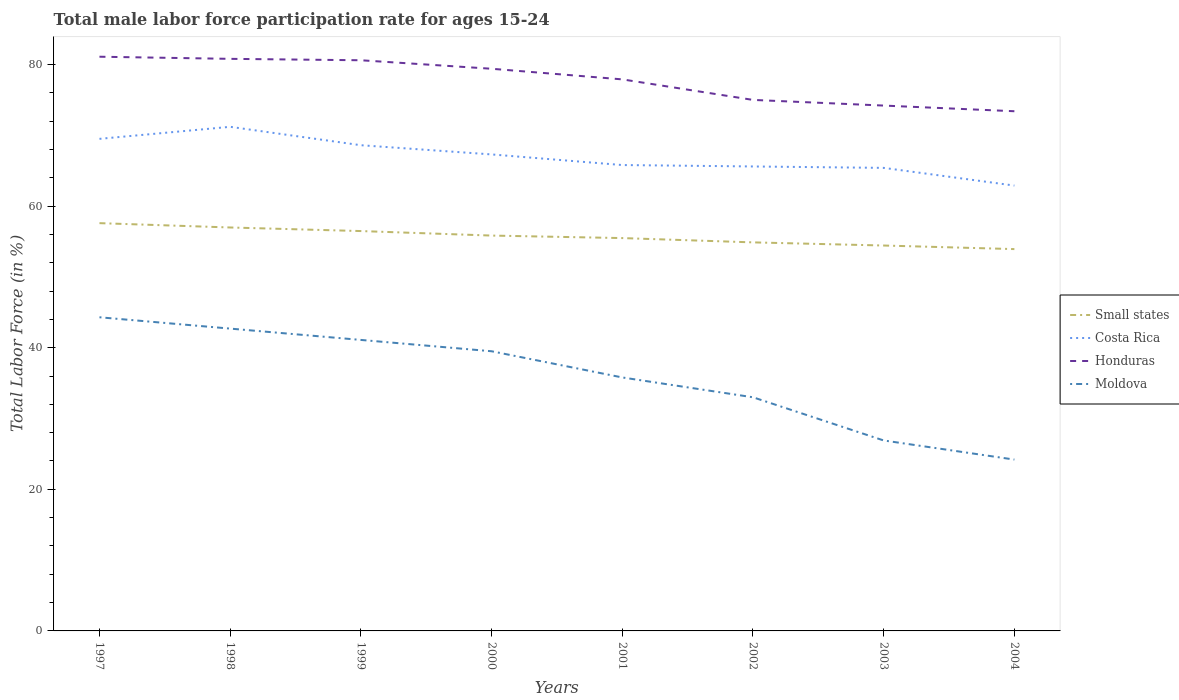How many different coloured lines are there?
Your answer should be compact. 4. Does the line corresponding to Small states intersect with the line corresponding to Moldova?
Give a very brief answer. No. Across all years, what is the maximum male labor force participation rate in Honduras?
Offer a very short reply. 73.4. In which year was the male labor force participation rate in Costa Rica maximum?
Ensure brevity in your answer.  2004. What is the total male labor force participation rate in Costa Rica in the graph?
Make the answer very short. 3.7. What is the difference between the highest and the second highest male labor force participation rate in Honduras?
Offer a very short reply. 7.7. How many lines are there?
Ensure brevity in your answer.  4. How many years are there in the graph?
Make the answer very short. 8. Are the values on the major ticks of Y-axis written in scientific E-notation?
Provide a short and direct response. No. Where does the legend appear in the graph?
Provide a succinct answer. Center right. How are the legend labels stacked?
Ensure brevity in your answer.  Vertical. What is the title of the graph?
Provide a succinct answer. Total male labor force participation rate for ages 15-24. Does "Cabo Verde" appear as one of the legend labels in the graph?
Provide a succinct answer. No. What is the Total Labor Force (in %) in Small states in 1997?
Ensure brevity in your answer.  57.59. What is the Total Labor Force (in %) of Costa Rica in 1997?
Your answer should be compact. 69.5. What is the Total Labor Force (in %) in Honduras in 1997?
Keep it short and to the point. 81.1. What is the Total Labor Force (in %) in Moldova in 1997?
Make the answer very short. 44.3. What is the Total Labor Force (in %) in Small states in 1998?
Offer a terse response. 56.98. What is the Total Labor Force (in %) of Costa Rica in 1998?
Give a very brief answer. 71.2. What is the Total Labor Force (in %) of Honduras in 1998?
Give a very brief answer. 80.8. What is the Total Labor Force (in %) of Moldova in 1998?
Give a very brief answer. 42.7. What is the Total Labor Force (in %) of Small states in 1999?
Provide a short and direct response. 56.48. What is the Total Labor Force (in %) in Costa Rica in 1999?
Make the answer very short. 68.6. What is the Total Labor Force (in %) in Honduras in 1999?
Your answer should be compact. 80.6. What is the Total Labor Force (in %) of Moldova in 1999?
Offer a very short reply. 41.1. What is the Total Labor Force (in %) of Small states in 2000?
Provide a short and direct response. 55.84. What is the Total Labor Force (in %) in Costa Rica in 2000?
Offer a terse response. 67.3. What is the Total Labor Force (in %) of Honduras in 2000?
Your response must be concise. 79.4. What is the Total Labor Force (in %) in Moldova in 2000?
Keep it short and to the point. 39.5. What is the Total Labor Force (in %) in Small states in 2001?
Provide a succinct answer. 55.48. What is the Total Labor Force (in %) in Costa Rica in 2001?
Offer a very short reply. 65.8. What is the Total Labor Force (in %) in Honduras in 2001?
Provide a short and direct response. 77.9. What is the Total Labor Force (in %) of Moldova in 2001?
Your response must be concise. 35.8. What is the Total Labor Force (in %) of Small states in 2002?
Offer a very short reply. 54.88. What is the Total Labor Force (in %) in Costa Rica in 2002?
Make the answer very short. 65.6. What is the Total Labor Force (in %) of Honduras in 2002?
Provide a short and direct response. 75. What is the Total Labor Force (in %) of Small states in 2003?
Provide a succinct answer. 54.43. What is the Total Labor Force (in %) of Costa Rica in 2003?
Your response must be concise. 65.4. What is the Total Labor Force (in %) in Honduras in 2003?
Your answer should be very brief. 74.2. What is the Total Labor Force (in %) in Moldova in 2003?
Your answer should be very brief. 26.9. What is the Total Labor Force (in %) in Small states in 2004?
Offer a very short reply. 53.93. What is the Total Labor Force (in %) of Costa Rica in 2004?
Ensure brevity in your answer.  62.9. What is the Total Labor Force (in %) in Honduras in 2004?
Your answer should be compact. 73.4. What is the Total Labor Force (in %) in Moldova in 2004?
Ensure brevity in your answer.  24.2. Across all years, what is the maximum Total Labor Force (in %) of Small states?
Make the answer very short. 57.59. Across all years, what is the maximum Total Labor Force (in %) of Costa Rica?
Your answer should be very brief. 71.2. Across all years, what is the maximum Total Labor Force (in %) of Honduras?
Offer a very short reply. 81.1. Across all years, what is the maximum Total Labor Force (in %) of Moldova?
Provide a succinct answer. 44.3. Across all years, what is the minimum Total Labor Force (in %) in Small states?
Offer a very short reply. 53.93. Across all years, what is the minimum Total Labor Force (in %) in Costa Rica?
Give a very brief answer. 62.9. Across all years, what is the minimum Total Labor Force (in %) of Honduras?
Provide a succinct answer. 73.4. Across all years, what is the minimum Total Labor Force (in %) in Moldova?
Provide a succinct answer. 24.2. What is the total Total Labor Force (in %) of Small states in the graph?
Your answer should be very brief. 445.62. What is the total Total Labor Force (in %) in Costa Rica in the graph?
Provide a short and direct response. 536.3. What is the total Total Labor Force (in %) in Honduras in the graph?
Make the answer very short. 622.4. What is the total Total Labor Force (in %) of Moldova in the graph?
Offer a very short reply. 287.5. What is the difference between the Total Labor Force (in %) in Small states in 1997 and that in 1998?
Your response must be concise. 0.61. What is the difference between the Total Labor Force (in %) of Costa Rica in 1997 and that in 1998?
Make the answer very short. -1.7. What is the difference between the Total Labor Force (in %) of Honduras in 1997 and that in 1998?
Ensure brevity in your answer.  0.3. What is the difference between the Total Labor Force (in %) in Small states in 1997 and that in 1999?
Provide a succinct answer. 1.12. What is the difference between the Total Labor Force (in %) of Costa Rica in 1997 and that in 1999?
Your answer should be very brief. 0.9. What is the difference between the Total Labor Force (in %) of Honduras in 1997 and that in 1999?
Offer a very short reply. 0.5. What is the difference between the Total Labor Force (in %) in Moldova in 1997 and that in 1999?
Your response must be concise. 3.2. What is the difference between the Total Labor Force (in %) in Small states in 1997 and that in 2000?
Your answer should be very brief. 1.75. What is the difference between the Total Labor Force (in %) in Costa Rica in 1997 and that in 2000?
Provide a short and direct response. 2.2. What is the difference between the Total Labor Force (in %) in Honduras in 1997 and that in 2000?
Offer a terse response. 1.7. What is the difference between the Total Labor Force (in %) in Small states in 1997 and that in 2001?
Provide a succinct answer. 2.11. What is the difference between the Total Labor Force (in %) of Small states in 1997 and that in 2002?
Your response must be concise. 2.72. What is the difference between the Total Labor Force (in %) of Honduras in 1997 and that in 2002?
Keep it short and to the point. 6.1. What is the difference between the Total Labor Force (in %) of Small states in 1997 and that in 2003?
Your answer should be compact. 3.16. What is the difference between the Total Labor Force (in %) in Honduras in 1997 and that in 2003?
Keep it short and to the point. 6.9. What is the difference between the Total Labor Force (in %) in Small states in 1997 and that in 2004?
Give a very brief answer. 3.67. What is the difference between the Total Labor Force (in %) in Honduras in 1997 and that in 2004?
Your answer should be compact. 7.7. What is the difference between the Total Labor Force (in %) of Moldova in 1997 and that in 2004?
Your answer should be very brief. 20.1. What is the difference between the Total Labor Force (in %) in Small states in 1998 and that in 1999?
Your response must be concise. 0.51. What is the difference between the Total Labor Force (in %) of Moldova in 1998 and that in 1999?
Your answer should be very brief. 1.6. What is the difference between the Total Labor Force (in %) of Small states in 1998 and that in 2000?
Keep it short and to the point. 1.14. What is the difference between the Total Labor Force (in %) in Costa Rica in 1998 and that in 2000?
Offer a very short reply. 3.9. What is the difference between the Total Labor Force (in %) in Moldova in 1998 and that in 2000?
Provide a short and direct response. 3.2. What is the difference between the Total Labor Force (in %) in Small states in 1998 and that in 2001?
Your response must be concise. 1.5. What is the difference between the Total Labor Force (in %) of Costa Rica in 1998 and that in 2001?
Your answer should be compact. 5.4. What is the difference between the Total Labor Force (in %) in Small states in 1998 and that in 2002?
Your response must be concise. 2.1. What is the difference between the Total Labor Force (in %) in Honduras in 1998 and that in 2002?
Ensure brevity in your answer.  5.8. What is the difference between the Total Labor Force (in %) of Moldova in 1998 and that in 2002?
Make the answer very short. 9.7. What is the difference between the Total Labor Force (in %) in Small states in 1998 and that in 2003?
Offer a terse response. 2.55. What is the difference between the Total Labor Force (in %) in Costa Rica in 1998 and that in 2003?
Ensure brevity in your answer.  5.8. What is the difference between the Total Labor Force (in %) in Honduras in 1998 and that in 2003?
Offer a terse response. 6.6. What is the difference between the Total Labor Force (in %) in Moldova in 1998 and that in 2003?
Give a very brief answer. 15.8. What is the difference between the Total Labor Force (in %) of Small states in 1998 and that in 2004?
Make the answer very short. 3.05. What is the difference between the Total Labor Force (in %) in Costa Rica in 1998 and that in 2004?
Make the answer very short. 8.3. What is the difference between the Total Labor Force (in %) of Small states in 1999 and that in 2000?
Your answer should be compact. 0.64. What is the difference between the Total Labor Force (in %) of Costa Rica in 1999 and that in 2000?
Your answer should be very brief. 1.3. What is the difference between the Total Labor Force (in %) of Honduras in 1999 and that in 2000?
Offer a very short reply. 1.2. What is the difference between the Total Labor Force (in %) in Moldova in 1999 and that in 2000?
Your answer should be compact. 1.6. What is the difference between the Total Labor Force (in %) of Small states in 1999 and that in 2001?
Ensure brevity in your answer.  0.99. What is the difference between the Total Labor Force (in %) of Honduras in 1999 and that in 2001?
Give a very brief answer. 2.7. What is the difference between the Total Labor Force (in %) in Moldova in 1999 and that in 2001?
Offer a very short reply. 5.3. What is the difference between the Total Labor Force (in %) of Small states in 1999 and that in 2002?
Keep it short and to the point. 1.6. What is the difference between the Total Labor Force (in %) of Costa Rica in 1999 and that in 2002?
Your answer should be compact. 3. What is the difference between the Total Labor Force (in %) in Small states in 1999 and that in 2003?
Provide a succinct answer. 2.04. What is the difference between the Total Labor Force (in %) in Costa Rica in 1999 and that in 2003?
Provide a short and direct response. 3.2. What is the difference between the Total Labor Force (in %) of Honduras in 1999 and that in 2003?
Your response must be concise. 6.4. What is the difference between the Total Labor Force (in %) of Small states in 1999 and that in 2004?
Ensure brevity in your answer.  2.55. What is the difference between the Total Labor Force (in %) of Honduras in 1999 and that in 2004?
Provide a succinct answer. 7.2. What is the difference between the Total Labor Force (in %) of Small states in 2000 and that in 2001?
Your answer should be very brief. 0.35. What is the difference between the Total Labor Force (in %) in Moldova in 2000 and that in 2001?
Your answer should be compact. 3.7. What is the difference between the Total Labor Force (in %) of Small states in 2000 and that in 2002?
Your answer should be very brief. 0.96. What is the difference between the Total Labor Force (in %) in Moldova in 2000 and that in 2002?
Make the answer very short. 6.5. What is the difference between the Total Labor Force (in %) of Small states in 2000 and that in 2003?
Keep it short and to the point. 1.4. What is the difference between the Total Labor Force (in %) of Costa Rica in 2000 and that in 2003?
Offer a terse response. 1.9. What is the difference between the Total Labor Force (in %) in Moldova in 2000 and that in 2003?
Make the answer very short. 12.6. What is the difference between the Total Labor Force (in %) in Small states in 2000 and that in 2004?
Your answer should be compact. 1.91. What is the difference between the Total Labor Force (in %) in Costa Rica in 2000 and that in 2004?
Make the answer very short. 4.4. What is the difference between the Total Labor Force (in %) of Small states in 2001 and that in 2002?
Offer a very short reply. 0.61. What is the difference between the Total Labor Force (in %) of Small states in 2001 and that in 2003?
Your answer should be very brief. 1.05. What is the difference between the Total Labor Force (in %) in Honduras in 2001 and that in 2003?
Offer a very short reply. 3.7. What is the difference between the Total Labor Force (in %) of Small states in 2001 and that in 2004?
Give a very brief answer. 1.56. What is the difference between the Total Labor Force (in %) in Honduras in 2001 and that in 2004?
Make the answer very short. 4.5. What is the difference between the Total Labor Force (in %) in Moldova in 2001 and that in 2004?
Give a very brief answer. 11.6. What is the difference between the Total Labor Force (in %) in Small states in 2002 and that in 2003?
Give a very brief answer. 0.44. What is the difference between the Total Labor Force (in %) of Costa Rica in 2002 and that in 2003?
Provide a succinct answer. 0.2. What is the difference between the Total Labor Force (in %) in Small states in 2002 and that in 2004?
Offer a very short reply. 0.95. What is the difference between the Total Labor Force (in %) of Costa Rica in 2002 and that in 2004?
Ensure brevity in your answer.  2.7. What is the difference between the Total Labor Force (in %) of Small states in 2003 and that in 2004?
Make the answer very short. 0.51. What is the difference between the Total Labor Force (in %) in Honduras in 2003 and that in 2004?
Provide a succinct answer. 0.8. What is the difference between the Total Labor Force (in %) of Small states in 1997 and the Total Labor Force (in %) of Costa Rica in 1998?
Your response must be concise. -13.61. What is the difference between the Total Labor Force (in %) of Small states in 1997 and the Total Labor Force (in %) of Honduras in 1998?
Your answer should be very brief. -23.21. What is the difference between the Total Labor Force (in %) in Small states in 1997 and the Total Labor Force (in %) in Moldova in 1998?
Provide a succinct answer. 14.89. What is the difference between the Total Labor Force (in %) of Costa Rica in 1997 and the Total Labor Force (in %) of Honduras in 1998?
Your answer should be very brief. -11.3. What is the difference between the Total Labor Force (in %) in Costa Rica in 1997 and the Total Labor Force (in %) in Moldova in 1998?
Keep it short and to the point. 26.8. What is the difference between the Total Labor Force (in %) of Honduras in 1997 and the Total Labor Force (in %) of Moldova in 1998?
Your answer should be compact. 38.4. What is the difference between the Total Labor Force (in %) of Small states in 1997 and the Total Labor Force (in %) of Costa Rica in 1999?
Give a very brief answer. -11.01. What is the difference between the Total Labor Force (in %) of Small states in 1997 and the Total Labor Force (in %) of Honduras in 1999?
Ensure brevity in your answer.  -23.01. What is the difference between the Total Labor Force (in %) of Small states in 1997 and the Total Labor Force (in %) of Moldova in 1999?
Your answer should be compact. 16.49. What is the difference between the Total Labor Force (in %) in Costa Rica in 1997 and the Total Labor Force (in %) in Honduras in 1999?
Your answer should be compact. -11.1. What is the difference between the Total Labor Force (in %) of Costa Rica in 1997 and the Total Labor Force (in %) of Moldova in 1999?
Give a very brief answer. 28.4. What is the difference between the Total Labor Force (in %) in Honduras in 1997 and the Total Labor Force (in %) in Moldova in 1999?
Offer a very short reply. 40. What is the difference between the Total Labor Force (in %) in Small states in 1997 and the Total Labor Force (in %) in Costa Rica in 2000?
Offer a terse response. -9.71. What is the difference between the Total Labor Force (in %) of Small states in 1997 and the Total Labor Force (in %) of Honduras in 2000?
Ensure brevity in your answer.  -21.81. What is the difference between the Total Labor Force (in %) in Small states in 1997 and the Total Labor Force (in %) in Moldova in 2000?
Your answer should be compact. 18.09. What is the difference between the Total Labor Force (in %) of Costa Rica in 1997 and the Total Labor Force (in %) of Moldova in 2000?
Offer a very short reply. 30. What is the difference between the Total Labor Force (in %) in Honduras in 1997 and the Total Labor Force (in %) in Moldova in 2000?
Ensure brevity in your answer.  41.6. What is the difference between the Total Labor Force (in %) in Small states in 1997 and the Total Labor Force (in %) in Costa Rica in 2001?
Make the answer very short. -8.21. What is the difference between the Total Labor Force (in %) of Small states in 1997 and the Total Labor Force (in %) of Honduras in 2001?
Provide a short and direct response. -20.31. What is the difference between the Total Labor Force (in %) of Small states in 1997 and the Total Labor Force (in %) of Moldova in 2001?
Ensure brevity in your answer.  21.79. What is the difference between the Total Labor Force (in %) in Costa Rica in 1997 and the Total Labor Force (in %) in Honduras in 2001?
Your answer should be very brief. -8.4. What is the difference between the Total Labor Force (in %) of Costa Rica in 1997 and the Total Labor Force (in %) of Moldova in 2001?
Provide a succinct answer. 33.7. What is the difference between the Total Labor Force (in %) in Honduras in 1997 and the Total Labor Force (in %) in Moldova in 2001?
Provide a short and direct response. 45.3. What is the difference between the Total Labor Force (in %) of Small states in 1997 and the Total Labor Force (in %) of Costa Rica in 2002?
Your response must be concise. -8.01. What is the difference between the Total Labor Force (in %) of Small states in 1997 and the Total Labor Force (in %) of Honduras in 2002?
Offer a terse response. -17.41. What is the difference between the Total Labor Force (in %) of Small states in 1997 and the Total Labor Force (in %) of Moldova in 2002?
Give a very brief answer. 24.59. What is the difference between the Total Labor Force (in %) in Costa Rica in 1997 and the Total Labor Force (in %) in Honduras in 2002?
Offer a very short reply. -5.5. What is the difference between the Total Labor Force (in %) of Costa Rica in 1997 and the Total Labor Force (in %) of Moldova in 2002?
Your answer should be compact. 36.5. What is the difference between the Total Labor Force (in %) of Honduras in 1997 and the Total Labor Force (in %) of Moldova in 2002?
Your answer should be very brief. 48.1. What is the difference between the Total Labor Force (in %) in Small states in 1997 and the Total Labor Force (in %) in Costa Rica in 2003?
Offer a terse response. -7.81. What is the difference between the Total Labor Force (in %) in Small states in 1997 and the Total Labor Force (in %) in Honduras in 2003?
Keep it short and to the point. -16.61. What is the difference between the Total Labor Force (in %) of Small states in 1997 and the Total Labor Force (in %) of Moldova in 2003?
Your response must be concise. 30.69. What is the difference between the Total Labor Force (in %) of Costa Rica in 1997 and the Total Labor Force (in %) of Honduras in 2003?
Provide a succinct answer. -4.7. What is the difference between the Total Labor Force (in %) of Costa Rica in 1997 and the Total Labor Force (in %) of Moldova in 2003?
Offer a terse response. 42.6. What is the difference between the Total Labor Force (in %) of Honduras in 1997 and the Total Labor Force (in %) of Moldova in 2003?
Keep it short and to the point. 54.2. What is the difference between the Total Labor Force (in %) of Small states in 1997 and the Total Labor Force (in %) of Costa Rica in 2004?
Provide a succinct answer. -5.31. What is the difference between the Total Labor Force (in %) of Small states in 1997 and the Total Labor Force (in %) of Honduras in 2004?
Keep it short and to the point. -15.81. What is the difference between the Total Labor Force (in %) of Small states in 1997 and the Total Labor Force (in %) of Moldova in 2004?
Your response must be concise. 33.39. What is the difference between the Total Labor Force (in %) of Costa Rica in 1997 and the Total Labor Force (in %) of Honduras in 2004?
Your answer should be very brief. -3.9. What is the difference between the Total Labor Force (in %) of Costa Rica in 1997 and the Total Labor Force (in %) of Moldova in 2004?
Offer a terse response. 45.3. What is the difference between the Total Labor Force (in %) of Honduras in 1997 and the Total Labor Force (in %) of Moldova in 2004?
Your answer should be very brief. 56.9. What is the difference between the Total Labor Force (in %) in Small states in 1998 and the Total Labor Force (in %) in Costa Rica in 1999?
Ensure brevity in your answer.  -11.62. What is the difference between the Total Labor Force (in %) in Small states in 1998 and the Total Labor Force (in %) in Honduras in 1999?
Your answer should be compact. -23.62. What is the difference between the Total Labor Force (in %) in Small states in 1998 and the Total Labor Force (in %) in Moldova in 1999?
Your answer should be very brief. 15.88. What is the difference between the Total Labor Force (in %) in Costa Rica in 1998 and the Total Labor Force (in %) in Moldova in 1999?
Provide a short and direct response. 30.1. What is the difference between the Total Labor Force (in %) of Honduras in 1998 and the Total Labor Force (in %) of Moldova in 1999?
Ensure brevity in your answer.  39.7. What is the difference between the Total Labor Force (in %) in Small states in 1998 and the Total Labor Force (in %) in Costa Rica in 2000?
Your answer should be very brief. -10.32. What is the difference between the Total Labor Force (in %) of Small states in 1998 and the Total Labor Force (in %) of Honduras in 2000?
Offer a very short reply. -22.42. What is the difference between the Total Labor Force (in %) in Small states in 1998 and the Total Labor Force (in %) in Moldova in 2000?
Your answer should be compact. 17.48. What is the difference between the Total Labor Force (in %) in Costa Rica in 1998 and the Total Labor Force (in %) in Honduras in 2000?
Your response must be concise. -8.2. What is the difference between the Total Labor Force (in %) of Costa Rica in 1998 and the Total Labor Force (in %) of Moldova in 2000?
Offer a very short reply. 31.7. What is the difference between the Total Labor Force (in %) in Honduras in 1998 and the Total Labor Force (in %) in Moldova in 2000?
Your response must be concise. 41.3. What is the difference between the Total Labor Force (in %) of Small states in 1998 and the Total Labor Force (in %) of Costa Rica in 2001?
Offer a terse response. -8.82. What is the difference between the Total Labor Force (in %) of Small states in 1998 and the Total Labor Force (in %) of Honduras in 2001?
Your answer should be very brief. -20.92. What is the difference between the Total Labor Force (in %) of Small states in 1998 and the Total Labor Force (in %) of Moldova in 2001?
Give a very brief answer. 21.18. What is the difference between the Total Labor Force (in %) of Costa Rica in 1998 and the Total Labor Force (in %) of Honduras in 2001?
Keep it short and to the point. -6.7. What is the difference between the Total Labor Force (in %) of Costa Rica in 1998 and the Total Labor Force (in %) of Moldova in 2001?
Your response must be concise. 35.4. What is the difference between the Total Labor Force (in %) in Small states in 1998 and the Total Labor Force (in %) in Costa Rica in 2002?
Ensure brevity in your answer.  -8.62. What is the difference between the Total Labor Force (in %) of Small states in 1998 and the Total Labor Force (in %) of Honduras in 2002?
Your answer should be very brief. -18.02. What is the difference between the Total Labor Force (in %) of Small states in 1998 and the Total Labor Force (in %) of Moldova in 2002?
Offer a terse response. 23.98. What is the difference between the Total Labor Force (in %) in Costa Rica in 1998 and the Total Labor Force (in %) in Honduras in 2002?
Provide a succinct answer. -3.8. What is the difference between the Total Labor Force (in %) of Costa Rica in 1998 and the Total Labor Force (in %) of Moldova in 2002?
Make the answer very short. 38.2. What is the difference between the Total Labor Force (in %) of Honduras in 1998 and the Total Labor Force (in %) of Moldova in 2002?
Your answer should be compact. 47.8. What is the difference between the Total Labor Force (in %) in Small states in 1998 and the Total Labor Force (in %) in Costa Rica in 2003?
Keep it short and to the point. -8.42. What is the difference between the Total Labor Force (in %) of Small states in 1998 and the Total Labor Force (in %) of Honduras in 2003?
Give a very brief answer. -17.22. What is the difference between the Total Labor Force (in %) in Small states in 1998 and the Total Labor Force (in %) in Moldova in 2003?
Keep it short and to the point. 30.08. What is the difference between the Total Labor Force (in %) in Costa Rica in 1998 and the Total Labor Force (in %) in Moldova in 2003?
Provide a succinct answer. 44.3. What is the difference between the Total Labor Force (in %) of Honduras in 1998 and the Total Labor Force (in %) of Moldova in 2003?
Keep it short and to the point. 53.9. What is the difference between the Total Labor Force (in %) of Small states in 1998 and the Total Labor Force (in %) of Costa Rica in 2004?
Offer a terse response. -5.92. What is the difference between the Total Labor Force (in %) of Small states in 1998 and the Total Labor Force (in %) of Honduras in 2004?
Make the answer very short. -16.42. What is the difference between the Total Labor Force (in %) of Small states in 1998 and the Total Labor Force (in %) of Moldova in 2004?
Offer a very short reply. 32.78. What is the difference between the Total Labor Force (in %) of Costa Rica in 1998 and the Total Labor Force (in %) of Honduras in 2004?
Keep it short and to the point. -2.2. What is the difference between the Total Labor Force (in %) in Costa Rica in 1998 and the Total Labor Force (in %) in Moldova in 2004?
Provide a short and direct response. 47. What is the difference between the Total Labor Force (in %) of Honduras in 1998 and the Total Labor Force (in %) of Moldova in 2004?
Offer a terse response. 56.6. What is the difference between the Total Labor Force (in %) of Small states in 1999 and the Total Labor Force (in %) of Costa Rica in 2000?
Offer a very short reply. -10.82. What is the difference between the Total Labor Force (in %) of Small states in 1999 and the Total Labor Force (in %) of Honduras in 2000?
Provide a succinct answer. -22.92. What is the difference between the Total Labor Force (in %) in Small states in 1999 and the Total Labor Force (in %) in Moldova in 2000?
Provide a short and direct response. 16.98. What is the difference between the Total Labor Force (in %) in Costa Rica in 1999 and the Total Labor Force (in %) in Honduras in 2000?
Provide a succinct answer. -10.8. What is the difference between the Total Labor Force (in %) in Costa Rica in 1999 and the Total Labor Force (in %) in Moldova in 2000?
Provide a succinct answer. 29.1. What is the difference between the Total Labor Force (in %) in Honduras in 1999 and the Total Labor Force (in %) in Moldova in 2000?
Offer a very short reply. 41.1. What is the difference between the Total Labor Force (in %) of Small states in 1999 and the Total Labor Force (in %) of Costa Rica in 2001?
Provide a short and direct response. -9.32. What is the difference between the Total Labor Force (in %) of Small states in 1999 and the Total Labor Force (in %) of Honduras in 2001?
Your response must be concise. -21.42. What is the difference between the Total Labor Force (in %) in Small states in 1999 and the Total Labor Force (in %) in Moldova in 2001?
Provide a succinct answer. 20.68. What is the difference between the Total Labor Force (in %) in Costa Rica in 1999 and the Total Labor Force (in %) in Moldova in 2001?
Provide a succinct answer. 32.8. What is the difference between the Total Labor Force (in %) of Honduras in 1999 and the Total Labor Force (in %) of Moldova in 2001?
Your response must be concise. 44.8. What is the difference between the Total Labor Force (in %) in Small states in 1999 and the Total Labor Force (in %) in Costa Rica in 2002?
Ensure brevity in your answer.  -9.12. What is the difference between the Total Labor Force (in %) in Small states in 1999 and the Total Labor Force (in %) in Honduras in 2002?
Your response must be concise. -18.52. What is the difference between the Total Labor Force (in %) in Small states in 1999 and the Total Labor Force (in %) in Moldova in 2002?
Provide a succinct answer. 23.48. What is the difference between the Total Labor Force (in %) of Costa Rica in 1999 and the Total Labor Force (in %) of Honduras in 2002?
Offer a very short reply. -6.4. What is the difference between the Total Labor Force (in %) of Costa Rica in 1999 and the Total Labor Force (in %) of Moldova in 2002?
Offer a terse response. 35.6. What is the difference between the Total Labor Force (in %) of Honduras in 1999 and the Total Labor Force (in %) of Moldova in 2002?
Make the answer very short. 47.6. What is the difference between the Total Labor Force (in %) of Small states in 1999 and the Total Labor Force (in %) of Costa Rica in 2003?
Ensure brevity in your answer.  -8.92. What is the difference between the Total Labor Force (in %) of Small states in 1999 and the Total Labor Force (in %) of Honduras in 2003?
Your answer should be very brief. -17.72. What is the difference between the Total Labor Force (in %) in Small states in 1999 and the Total Labor Force (in %) in Moldova in 2003?
Your answer should be compact. 29.58. What is the difference between the Total Labor Force (in %) of Costa Rica in 1999 and the Total Labor Force (in %) of Moldova in 2003?
Offer a very short reply. 41.7. What is the difference between the Total Labor Force (in %) of Honduras in 1999 and the Total Labor Force (in %) of Moldova in 2003?
Give a very brief answer. 53.7. What is the difference between the Total Labor Force (in %) of Small states in 1999 and the Total Labor Force (in %) of Costa Rica in 2004?
Provide a short and direct response. -6.42. What is the difference between the Total Labor Force (in %) of Small states in 1999 and the Total Labor Force (in %) of Honduras in 2004?
Give a very brief answer. -16.92. What is the difference between the Total Labor Force (in %) in Small states in 1999 and the Total Labor Force (in %) in Moldova in 2004?
Ensure brevity in your answer.  32.28. What is the difference between the Total Labor Force (in %) in Costa Rica in 1999 and the Total Labor Force (in %) in Honduras in 2004?
Ensure brevity in your answer.  -4.8. What is the difference between the Total Labor Force (in %) of Costa Rica in 1999 and the Total Labor Force (in %) of Moldova in 2004?
Provide a short and direct response. 44.4. What is the difference between the Total Labor Force (in %) in Honduras in 1999 and the Total Labor Force (in %) in Moldova in 2004?
Offer a very short reply. 56.4. What is the difference between the Total Labor Force (in %) in Small states in 2000 and the Total Labor Force (in %) in Costa Rica in 2001?
Offer a terse response. -9.96. What is the difference between the Total Labor Force (in %) of Small states in 2000 and the Total Labor Force (in %) of Honduras in 2001?
Provide a short and direct response. -22.06. What is the difference between the Total Labor Force (in %) of Small states in 2000 and the Total Labor Force (in %) of Moldova in 2001?
Keep it short and to the point. 20.04. What is the difference between the Total Labor Force (in %) in Costa Rica in 2000 and the Total Labor Force (in %) in Moldova in 2001?
Make the answer very short. 31.5. What is the difference between the Total Labor Force (in %) in Honduras in 2000 and the Total Labor Force (in %) in Moldova in 2001?
Give a very brief answer. 43.6. What is the difference between the Total Labor Force (in %) in Small states in 2000 and the Total Labor Force (in %) in Costa Rica in 2002?
Your answer should be compact. -9.76. What is the difference between the Total Labor Force (in %) of Small states in 2000 and the Total Labor Force (in %) of Honduras in 2002?
Offer a very short reply. -19.16. What is the difference between the Total Labor Force (in %) in Small states in 2000 and the Total Labor Force (in %) in Moldova in 2002?
Make the answer very short. 22.84. What is the difference between the Total Labor Force (in %) of Costa Rica in 2000 and the Total Labor Force (in %) of Moldova in 2002?
Your response must be concise. 34.3. What is the difference between the Total Labor Force (in %) of Honduras in 2000 and the Total Labor Force (in %) of Moldova in 2002?
Ensure brevity in your answer.  46.4. What is the difference between the Total Labor Force (in %) of Small states in 2000 and the Total Labor Force (in %) of Costa Rica in 2003?
Your response must be concise. -9.56. What is the difference between the Total Labor Force (in %) in Small states in 2000 and the Total Labor Force (in %) in Honduras in 2003?
Your response must be concise. -18.36. What is the difference between the Total Labor Force (in %) in Small states in 2000 and the Total Labor Force (in %) in Moldova in 2003?
Make the answer very short. 28.94. What is the difference between the Total Labor Force (in %) of Costa Rica in 2000 and the Total Labor Force (in %) of Honduras in 2003?
Ensure brevity in your answer.  -6.9. What is the difference between the Total Labor Force (in %) in Costa Rica in 2000 and the Total Labor Force (in %) in Moldova in 2003?
Offer a terse response. 40.4. What is the difference between the Total Labor Force (in %) in Honduras in 2000 and the Total Labor Force (in %) in Moldova in 2003?
Keep it short and to the point. 52.5. What is the difference between the Total Labor Force (in %) of Small states in 2000 and the Total Labor Force (in %) of Costa Rica in 2004?
Provide a short and direct response. -7.06. What is the difference between the Total Labor Force (in %) in Small states in 2000 and the Total Labor Force (in %) in Honduras in 2004?
Give a very brief answer. -17.56. What is the difference between the Total Labor Force (in %) in Small states in 2000 and the Total Labor Force (in %) in Moldova in 2004?
Provide a succinct answer. 31.64. What is the difference between the Total Labor Force (in %) of Costa Rica in 2000 and the Total Labor Force (in %) of Moldova in 2004?
Your answer should be compact. 43.1. What is the difference between the Total Labor Force (in %) of Honduras in 2000 and the Total Labor Force (in %) of Moldova in 2004?
Provide a succinct answer. 55.2. What is the difference between the Total Labor Force (in %) of Small states in 2001 and the Total Labor Force (in %) of Costa Rica in 2002?
Provide a succinct answer. -10.12. What is the difference between the Total Labor Force (in %) in Small states in 2001 and the Total Labor Force (in %) in Honduras in 2002?
Provide a succinct answer. -19.52. What is the difference between the Total Labor Force (in %) in Small states in 2001 and the Total Labor Force (in %) in Moldova in 2002?
Your response must be concise. 22.48. What is the difference between the Total Labor Force (in %) of Costa Rica in 2001 and the Total Labor Force (in %) of Honduras in 2002?
Your answer should be very brief. -9.2. What is the difference between the Total Labor Force (in %) in Costa Rica in 2001 and the Total Labor Force (in %) in Moldova in 2002?
Keep it short and to the point. 32.8. What is the difference between the Total Labor Force (in %) of Honduras in 2001 and the Total Labor Force (in %) of Moldova in 2002?
Provide a succinct answer. 44.9. What is the difference between the Total Labor Force (in %) in Small states in 2001 and the Total Labor Force (in %) in Costa Rica in 2003?
Your response must be concise. -9.92. What is the difference between the Total Labor Force (in %) in Small states in 2001 and the Total Labor Force (in %) in Honduras in 2003?
Your answer should be compact. -18.72. What is the difference between the Total Labor Force (in %) in Small states in 2001 and the Total Labor Force (in %) in Moldova in 2003?
Provide a succinct answer. 28.58. What is the difference between the Total Labor Force (in %) in Costa Rica in 2001 and the Total Labor Force (in %) in Moldova in 2003?
Offer a terse response. 38.9. What is the difference between the Total Labor Force (in %) of Honduras in 2001 and the Total Labor Force (in %) of Moldova in 2003?
Provide a short and direct response. 51. What is the difference between the Total Labor Force (in %) of Small states in 2001 and the Total Labor Force (in %) of Costa Rica in 2004?
Give a very brief answer. -7.42. What is the difference between the Total Labor Force (in %) of Small states in 2001 and the Total Labor Force (in %) of Honduras in 2004?
Ensure brevity in your answer.  -17.92. What is the difference between the Total Labor Force (in %) of Small states in 2001 and the Total Labor Force (in %) of Moldova in 2004?
Your response must be concise. 31.28. What is the difference between the Total Labor Force (in %) in Costa Rica in 2001 and the Total Labor Force (in %) in Honduras in 2004?
Keep it short and to the point. -7.6. What is the difference between the Total Labor Force (in %) in Costa Rica in 2001 and the Total Labor Force (in %) in Moldova in 2004?
Offer a very short reply. 41.6. What is the difference between the Total Labor Force (in %) in Honduras in 2001 and the Total Labor Force (in %) in Moldova in 2004?
Your answer should be very brief. 53.7. What is the difference between the Total Labor Force (in %) in Small states in 2002 and the Total Labor Force (in %) in Costa Rica in 2003?
Your answer should be compact. -10.52. What is the difference between the Total Labor Force (in %) of Small states in 2002 and the Total Labor Force (in %) of Honduras in 2003?
Make the answer very short. -19.32. What is the difference between the Total Labor Force (in %) of Small states in 2002 and the Total Labor Force (in %) of Moldova in 2003?
Ensure brevity in your answer.  27.98. What is the difference between the Total Labor Force (in %) in Costa Rica in 2002 and the Total Labor Force (in %) in Honduras in 2003?
Ensure brevity in your answer.  -8.6. What is the difference between the Total Labor Force (in %) in Costa Rica in 2002 and the Total Labor Force (in %) in Moldova in 2003?
Ensure brevity in your answer.  38.7. What is the difference between the Total Labor Force (in %) in Honduras in 2002 and the Total Labor Force (in %) in Moldova in 2003?
Provide a succinct answer. 48.1. What is the difference between the Total Labor Force (in %) of Small states in 2002 and the Total Labor Force (in %) of Costa Rica in 2004?
Keep it short and to the point. -8.02. What is the difference between the Total Labor Force (in %) of Small states in 2002 and the Total Labor Force (in %) of Honduras in 2004?
Offer a very short reply. -18.52. What is the difference between the Total Labor Force (in %) of Small states in 2002 and the Total Labor Force (in %) of Moldova in 2004?
Keep it short and to the point. 30.68. What is the difference between the Total Labor Force (in %) in Costa Rica in 2002 and the Total Labor Force (in %) in Moldova in 2004?
Offer a very short reply. 41.4. What is the difference between the Total Labor Force (in %) in Honduras in 2002 and the Total Labor Force (in %) in Moldova in 2004?
Your response must be concise. 50.8. What is the difference between the Total Labor Force (in %) of Small states in 2003 and the Total Labor Force (in %) of Costa Rica in 2004?
Offer a very short reply. -8.47. What is the difference between the Total Labor Force (in %) in Small states in 2003 and the Total Labor Force (in %) in Honduras in 2004?
Your response must be concise. -18.97. What is the difference between the Total Labor Force (in %) of Small states in 2003 and the Total Labor Force (in %) of Moldova in 2004?
Offer a terse response. 30.23. What is the difference between the Total Labor Force (in %) in Costa Rica in 2003 and the Total Labor Force (in %) in Moldova in 2004?
Provide a succinct answer. 41.2. What is the average Total Labor Force (in %) in Small states per year?
Your response must be concise. 55.7. What is the average Total Labor Force (in %) in Costa Rica per year?
Your answer should be compact. 67.04. What is the average Total Labor Force (in %) of Honduras per year?
Provide a short and direct response. 77.8. What is the average Total Labor Force (in %) of Moldova per year?
Make the answer very short. 35.94. In the year 1997, what is the difference between the Total Labor Force (in %) in Small states and Total Labor Force (in %) in Costa Rica?
Offer a very short reply. -11.91. In the year 1997, what is the difference between the Total Labor Force (in %) of Small states and Total Labor Force (in %) of Honduras?
Ensure brevity in your answer.  -23.51. In the year 1997, what is the difference between the Total Labor Force (in %) of Small states and Total Labor Force (in %) of Moldova?
Offer a very short reply. 13.29. In the year 1997, what is the difference between the Total Labor Force (in %) of Costa Rica and Total Labor Force (in %) of Honduras?
Your answer should be very brief. -11.6. In the year 1997, what is the difference between the Total Labor Force (in %) of Costa Rica and Total Labor Force (in %) of Moldova?
Provide a short and direct response. 25.2. In the year 1997, what is the difference between the Total Labor Force (in %) in Honduras and Total Labor Force (in %) in Moldova?
Your response must be concise. 36.8. In the year 1998, what is the difference between the Total Labor Force (in %) of Small states and Total Labor Force (in %) of Costa Rica?
Offer a very short reply. -14.22. In the year 1998, what is the difference between the Total Labor Force (in %) in Small states and Total Labor Force (in %) in Honduras?
Offer a very short reply. -23.82. In the year 1998, what is the difference between the Total Labor Force (in %) of Small states and Total Labor Force (in %) of Moldova?
Offer a terse response. 14.28. In the year 1998, what is the difference between the Total Labor Force (in %) in Costa Rica and Total Labor Force (in %) in Honduras?
Ensure brevity in your answer.  -9.6. In the year 1998, what is the difference between the Total Labor Force (in %) in Costa Rica and Total Labor Force (in %) in Moldova?
Your response must be concise. 28.5. In the year 1998, what is the difference between the Total Labor Force (in %) of Honduras and Total Labor Force (in %) of Moldova?
Give a very brief answer. 38.1. In the year 1999, what is the difference between the Total Labor Force (in %) of Small states and Total Labor Force (in %) of Costa Rica?
Your answer should be compact. -12.12. In the year 1999, what is the difference between the Total Labor Force (in %) of Small states and Total Labor Force (in %) of Honduras?
Make the answer very short. -24.12. In the year 1999, what is the difference between the Total Labor Force (in %) in Small states and Total Labor Force (in %) in Moldova?
Ensure brevity in your answer.  15.38. In the year 1999, what is the difference between the Total Labor Force (in %) of Honduras and Total Labor Force (in %) of Moldova?
Your answer should be compact. 39.5. In the year 2000, what is the difference between the Total Labor Force (in %) of Small states and Total Labor Force (in %) of Costa Rica?
Make the answer very short. -11.46. In the year 2000, what is the difference between the Total Labor Force (in %) in Small states and Total Labor Force (in %) in Honduras?
Offer a terse response. -23.56. In the year 2000, what is the difference between the Total Labor Force (in %) in Small states and Total Labor Force (in %) in Moldova?
Your response must be concise. 16.34. In the year 2000, what is the difference between the Total Labor Force (in %) in Costa Rica and Total Labor Force (in %) in Honduras?
Your answer should be very brief. -12.1. In the year 2000, what is the difference between the Total Labor Force (in %) in Costa Rica and Total Labor Force (in %) in Moldova?
Your answer should be compact. 27.8. In the year 2000, what is the difference between the Total Labor Force (in %) of Honduras and Total Labor Force (in %) of Moldova?
Give a very brief answer. 39.9. In the year 2001, what is the difference between the Total Labor Force (in %) of Small states and Total Labor Force (in %) of Costa Rica?
Your answer should be compact. -10.32. In the year 2001, what is the difference between the Total Labor Force (in %) in Small states and Total Labor Force (in %) in Honduras?
Provide a succinct answer. -22.42. In the year 2001, what is the difference between the Total Labor Force (in %) of Small states and Total Labor Force (in %) of Moldova?
Ensure brevity in your answer.  19.68. In the year 2001, what is the difference between the Total Labor Force (in %) of Costa Rica and Total Labor Force (in %) of Honduras?
Offer a very short reply. -12.1. In the year 2001, what is the difference between the Total Labor Force (in %) in Costa Rica and Total Labor Force (in %) in Moldova?
Your answer should be compact. 30. In the year 2001, what is the difference between the Total Labor Force (in %) in Honduras and Total Labor Force (in %) in Moldova?
Your response must be concise. 42.1. In the year 2002, what is the difference between the Total Labor Force (in %) of Small states and Total Labor Force (in %) of Costa Rica?
Offer a very short reply. -10.72. In the year 2002, what is the difference between the Total Labor Force (in %) in Small states and Total Labor Force (in %) in Honduras?
Your answer should be compact. -20.12. In the year 2002, what is the difference between the Total Labor Force (in %) of Small states and Total Labor Force (in %) of Moldova?
Provide a short and direct response. 21.88. In the year 2002, what is the difference between the Total Labor Force (in %) in Costa Rica and Total Labor Force (in %) in Honduras?
Offer a very short reply. -9.4. In the year 2002, what is the difference between the Total Labor Force (in %) of Costa Rica and Total Labor Force (in %) of Moldova?
Give a very brief answer. 32.6. In the year 2002, what is the difference between the Total Labor Force (in %) in Honduras and Total Labor Force (in %) in Moldova?
Offer a terse response. 42. In the year 2003, what is the difference between the Total Labor Force (in %) of Small states and Total Labor Force (in %) of Costa Rica?
Keep it short and to the point. -10.97. In the year 2003, what is the difference between the Total Labor Force (in %) in Small states and Total Labor Force (in %) in Honduras?
Provide a short and direct response. -19.77. In the year 2003, what is the difference between the Total Labor Force (in %) of Small states and Total Labor Force (in %) of Moldova?
Offer a very short reply. 27.53. In the year 2003, what is the difference between the Total Labor Force (in %) in Costa Rica and Total Labor Force (in %) in Moldova?
Your answer should be very brief. 38.5. In the year 2003, what is the difference between the Total Labor Force (in %) of Honduras and Total Labor Force (in %) of Moldova?
Your response must be concise. 47.3. In the year 2004, what is the difference between the Total Labor Force (in %) of Small states and Total Labor Force (in %) of Costa Rica?
Provide a short and direct response. -8.97. In the year 2004, what is the difference between the Total Labor Force (in %) of Small states and Total Labor Force (in %) of Honduras?
Your answer should be very brief. -19.47. In the year 2004, what is the difference between the Total Labor Force (in %) of Small states and Total Labor Force (in %) of Moldova?
Offer a terse response. 29.73. In the year 2004, what is the difference between the Total Labor Force (in %) of Costa Rica and Total Labor Force (in %) of Honduras?
Ensure brevity in your answer.  -10.5. In the year 2004, what is the difference between the Total Labor Force (in %) of Costa Rica and Total Labor Force (in %) of Moldova?
Offer a very short reply. 38.7. In the year 2004, what is the difference between the Total Labor Force (in %) in Honduras and Total Labor Force (in %) in Moldova?
Offer a terse response. 49.2. What is the ratio of the Total Labor Force (in %) of Small states in 1997 to that in 1998?
Provide a succinct answer. 1.01. What is the ratio of the Total Labor Force (in %) of Costa Rica in 1997 to that in 1998?
Your answer should be very brief. 0.98. What is the ratio of the Total Labor Force (in %) of Honduras in 1997 to that in 1998?
Offer a terse response. 1. What is the ratio of the Total Labor Force (in %) in Moldova in 1997 to that in 1998?
Make the answer very short. 1.04. What is the ratio of the Total Labor Force (in %) of Small states in 1997 to that in 1999?
Make the answer very short. 1.02. What is the ratio of the Total Labor Force (in %) in Costa Rica in 1997 to that in 1999?
Keep it short and to the point. 1.01. What is the ratio of the Total Labor Force (in %) in Honduras in 1997 to that in 1999?
Your answer should be very brief. 1.01. What is the ratio of the Total Labor Force (in %) of Moldova in 1997 to that in 1999?
Offer a terse response. 1.08. What is the ratio of the Total Labor Force (in %) of Small states in 1997 to that in 2000?
Make the answer very short. 1.03. What is the ratio of the Total Labor Force (in %) of Costa Rica in 1997 to that in 2000?
Offer a terse response. 1.03. What is the ratio of the Total Labor Force (in %) in Honduras in 1997 to that in 2000?
Your answer should be compact. 1.02. What is the ratio of the Total Labor Force (in %) in Moldova in 1997 to that in 2000?
Make the answer very short. 1.12. What is the ratio of the Total Labor Force (in %) of Small states in 1997 to that in 2001?
Offer a very short reply. 1.04. What is the ratio of the Total Labor Force (in %) of Costa Rica in 1997 to that in 2001?
Provide a succinct answer. 1.06. What is the ratio of the Total Labor Force (in %) of Honduras in 1997 to that in 2001?
Your response must be concise. 1.04. What is the ratio of the Total Labor Force (in %) of Moldova in 1997 to that in 2001?
Provide a succinct answer. 1.24. What is the ratio of the Total Labor Force (in %) in Small states in 1997 to that in 2002?
Provide a succinct answer. 1.05. What is the ratio of the Total Labor Force (in %) in Costa Rica in 1997 to that in 2002?
Provide a short and direct response. 1.06. What is the ratio of the Total Labor Force (in %) of Honduras in 1997 to that in 2002?
Keep it short and to the point. 1.08. What is the ratio of the Total Labor Force (in %) of Moldova in 1997 to that in 2002?
Your response must be concise. 1.34. What is the ratio of the Total Labor Force (in %) in Small states in 1997 to that in 2003?
Give a very brief answer. 1.06. What is the ratio of the Total Labor Force (in %) in Costa Rica in 1997 to that in 2003?
Keep it short and to the point. 1.06. What is the ratio of the Total Labor Force (in %) in Honduras in 1997 to that in 2003?
Provide a short and direct response. 1.09. What is the ratio of the Total Labor Force (in %) of Moldova in 1997 to that in 2003?
Provide a short and direct response. 1.65. What is the ratio of the Total Labor Force (in %) of Small states in 1997 to that in 2004?
Make the answer very short. 1.07. What is the ratio of the Total Labor Force (in %) in Costa Rica in 1997 to that in 2004?
Keep it short and to the point. 1.1. What is the ratio of the Total Labor Force (in %) of Honduras in 1997 to that in 2004?
Make the answer very short. 1.1. What is the ratio of the Total Labor Force (in %) in Moldova in 1997 to that in 2004?
Keep it short and to the point. 1.83. What is the ratio of the Total Labor Force (in %) of Small states in 1998 to that in 1999?
Your answer should be very brief. 1.01. What is the ratio of the Total Labor Force (in %) of Costa Rica in 1998 to that in 1999?
Offer a very short reply. 1.04. What is the ratio of the Total Labor Force (in %) of Moldova in 1998 to that in 1999?
Ensure brevity in your answer.  1.04. What is the ratio of the Total Labor Force (in %) in Small states in 1998 to that in 2000?
Provide a short and direct response. 1.02. What is the ratio of the Total Labor Force (in %) in Costa Rica in 1998 to that in 2000?
Your answer should be compact. 1.06. What is the ratio of the Total Labor Force (in %) of Honduras in 1998 to that in 2000?
Your answer should be very brief. 1.02. What is the ratio of the Total Labor Force (in %) in Moldova in 1998 to that in 2000?
Offer a terse response. 1.08. What is the ratio of the Total Labor Force (in %) in Small states in 1998 to that in 2001?
Ensure brevity in your answer.  1.03. What is the ratio of the Total Labor Force (in %) in Costa Rica in 1998 to that in 2001?
Your answer should be very brief. 1.08. What is the ratio of the Total Labor Force (in %) of Honduras in 1998 to that in 2001?
Make the answer very short. 1.04. What is the ratio of the Total Labor Force (in %) of Moldova in 1998 to that in 2001?
Provide a succinct answer. 1.19. What is the ratio of the Total Labor Force (in %) in Small states in 1998 to that in 2002?
Ensure brevity in your answer.  1.04. What is the ratio of the Total Labor Force (in %) in Costa Rica in 1998 to that in 2002?
Your response must be concise. 1.09. What is the ratio of the Total Labor Force (in %) of Honduras in 1998 to that in 2002?
Keep it short and to the point. 1.08. What is the ratio of the Total Labor Force (in %) in Moldova in 1998 to that in 2002?
Make the answer very short. 1.29. What is the ratio of the Total Labor Force (in %) of Small states in 1998 to that in 2003?
Provide a succinct answer. 1.05. What is the ratio of the Total Labor Force (in %) of Costa Rica in 1998 to that in 2003?
Give a very brief answer. 1.09. What is the ratio of the Total Labor Force (in %) in Honduras in 1998 to that in 2003?
Give a very brief answer. 1.09. What is the ratio of the Total Labor Force (in %) of Moldova in 1998 to that in 2003?
Keep it short and to the point. 1.59. What is the ratio of the Total Labor Force (in %) in Small states in 1998 to that in 2004?
Your answer should be compact. 1.06. What is the ratio of the Total Labor Force (in %) of Costa Rica in 1998 to that in 2004?
Provide a short and direct response. 1.13. What is the ratio of the Total Labor Force (in %) of Honduras in 1998 to that in 2004?
Offer a very short reply. 1.1. What is the ratio of the Total Labor Force (in %) in Moldova in 1998 to that in 2004?
Provide a short and direct response. 1.76. What is the ratio of the Total Labor Force (in %) in Small states in 1999 to that in 2000?
Provide a short and direct response. 1.01. What is the ratio of the Total Labor Force (in %) in Costa Rica in 1999 to that in 2000?
Your answer should be very brief. 1.02. What is the ratio of the Total Labor Force (in %) in Honduras in 1999 to that in 2000?
Make the answer very short. 1.02. What is the ratio of the Total Labor Force (in %) of Moldova in 1999 to that in 2000?
Provide a succinct answer. 1.04. What is the ratio of the Total Labor Force (in %) in Small states in 1999 to that in 2001?
Give a very brief answer. 1.02. What is the ratio of the Total Labor Force (in %) in Costa Rica in 1999 to that in 2001?
Your answer should be compact. 1.04. What is the ratio of the Total Labor Force (in %) of Honduras in 1999 to that in 2001?
Your response must be concise. 1.03. What is the ratio of the Total Labor Force (in %) of Moldova in 1999 to that in 2001?
Your answer should be very brief. 1.15. What is the ratio of the Total Labor Force (in %) of Small states in 1999 to that in 2002?
Provide a succinct answer. 1.03. What is the ratio of the Total Labor Force (in %) in Costa Rica in 1999 to that in 2002?
Offer a very short reply. 1.05. What is the ratio of the Total Labor Force (in %) in Honduras in 1999 to that in 2002?
Your answer should be compact. 1.07. What is the ratio of the Total Labor Force (in %) in Moldova in 1999 to that in 2002?
Your answer should be compact. 1.25. What is the ratio of the Total Labor Force (in %) in Small states in 1999 to that in 2003?
Provide a short and direct response. 1.04. What is the ratio of the Total Labor Force (in %) in Costa Rica in 1999 to that in 2003?
Your answer should be very brief. 1.05. What is the ratio of the Total Labor Force (in %) of Honduras in 1999 to that in 2003?
Ensure brevity in your answer.  1.09. What is the ratio of the Total Labor Force (in %) in Moldova in 1999 to that in 2003?
Provide a succinct answer. 1.53. What is the ratio of the Total Labor Force (in %) of Small states in 1999 to that in 2004?
Keep it short and to the point. 1.05. What is the ratio of the Total Labor Force (in %) in Costa Rica in 1999 to that in 2004?
Your answer should be very brief. 1.09. What is the ratio of the Total Labor Force (in %) in Honduras in 1999 to that in 2004?
Provide a succinct answer. 1.1. What is the ratio of the Total Labor Force (in %) in Moldova in 1999 to that in 2004?
Provide a short and direct response. 1.7. What is the ratio of the Total Labor Force (in %) in Small states in 2000 to that in 2001?
Ensure brevity in your answer.  1.01. What is the ratio of the Total Labor Force (in %) in Costa Rica in 2000 to that in 2001?
Offer a terse response. 1.02. What is the ratio of the Total Labor Force (in %) of Honduras in 2000 to that in 2001?
Offer a very short reply. 1.02. What is the ratio of the Total Labor Force (in %) in Moldova in 2000 to that in 2001?
Your answer should be compact. 1.1. What is the ratio of the Total Labor Force (in %) in Small states in 2000 to that in 2002?
Your answer should be very brief. 1.02. What is the ratio of the Total Labor Force (in %) of Costa Rica in 2000 to that in 2002?
Your response must be concise. 1.03. What is the ratio of the Total Labor Force (in %) in Honduras in 2000 to that in 2002?
Make the answer very short. 1.06. What is the ratio of the Total Labor Force (in %) of Moldova in 2000 to that in 2002?
Ensure brevity in your answer.  1.2. What is the ratio of the Total Labor Force (in %) of Small states in 2000 to that in 2003?
Give a very brief answer. 1.03. What is the ratio of the Total Labor Force (in %) in Costa Rica in 2000 to that in 2003?
Your answer should be very brief. 1.03. What is the ratio of the Total Labor Force (in %) of Honduras in 2000 to that in 2003?
Make the answer very short. 1.07. What is the ratio of the Total Labor Force (in %) in Moldova in 2000 to that in 2003?
Your response must be concise. 1.47. What is the ratio of the Total Labor Force (in %) in Small states in 2000 to that in 2004?
Offer a terse response. 1.04. What is the ratio of the Total Labor Force (in %) of Costa Rica in 2000 to that in 2004?
Offer a terse response. 1.07. What is the ratio of the Total Labor Force (in %) of Honduras in 2000 to that in 2004?
Make the answer very short. 1.08. What is the ratio of the Total Labor Force (in %) in Moldova in 2000 to that in 2004?
Provide a short and direct response. 1.63. What is the ratio of the Total Labor Force (in %) in Small states in 2001 to that in 2002?
Ensure brevity in your answer.  1.01. What is the ratio of the Total Labor Force (in %) of Costa Rica in 2001 to that in 2002?
Ensure brevity in your answer.  1. What is the ratio of the Total Labor Force (in %) of Honduras in 2001 to that in 2002?
Make the answer very short. 1.04. What is the ratio of the Total Labor Force (in %) of Moldova in 2001 to that in 2002?
Provide a short and direct response. 1.08. What is the ratio of the Total Labor Force (in %) of Small states in 2001 to that in 2003?
Your answer should be compact. 1.02. What is the ratio of the Total Labor Force (in %) of Honduras in 2001 to that in 2003?
Offer a terse response. 1.05. What is the ratio of the Total Labor Force (in %) of Moldova in 2001 to that in 2003?
Offer a terse response. 1.33. What is the ratio of the Total Labor Force (in %) of Small states in 2001 to that in 2004?
Your answer should be very brief. 1.03. What is the ratio of the Total Labor Force (in %) of Costa Rica in 2001 to that in 2004?
Your answer should be compact. 1.05. What is the ratio of the Total Labor Force (in %) in Honduras in 2001 to that in 2004?
Offer a very short reply. 1.06. What is the ratio of the Total Labor Force (in %) of Moldova in 2001 to that in 2004?
Offer a very short reply. 1.48. What is the ratio of the Total Labor Force (in %) of Small states in 2002 to that in 2003?
Keep it short and to the point. 1.01. What is the ratio of the Total Labor Force (in %) of Honduras in 2002 to that in 2003?
Offer a terse response. 1.01. What is the ratio of the Total Labor Force (in %) of Moldova in 2002 to that in 2003?
Your response must be concise. 1.23. What is the ratio of the Total Labor Force (in %) in Small states in 2002 to that in 2004?
Make the answer very short. 1.02. What is the ratio of the Total Labor Force (in %) of Costa Rica in 2002 to that in 2004?
Offer a very short reply. 1.04. What is the ratio of the Total Labor Force (in %) of Honduras in 2002 to that in 2004?
Offer a very short reply. 1.02. What is the ratio of the Total Labor Force (in %) of Moldova in 2002 to that in 2004?
Offer a very short reply. 1.36. What is the ratio of the Total Labor Force (in %) in Small states in 2003 to that in 2004?
Provide a succinct answer. 1.01. What is the ratio of the Total Labor Force (in %) in Costa Rica in 2003 to that in 2004?
Keep it short and to the point. 1.04. What is the ratio of the Total Labor Force (in %) of Honduras in 2003 to that in 2004?
Provide a succinct answer. 1.01. What is the ratio of the Total Labor Force (in %) of Moldova in 2003 to that in 2004?
Provide a succinct answer. 1.11. What is the difference between the highest and the second highest Total Labor Force (in %) in Small states?
Make the answer very short. 0.61. What is the difference between the highest and the second highest Total Labor Force (in %) in Costa Rica?
Make the answer very short. 1.7. What is the difference between the highest and the second highest Total Labor Force (in %) of Moldova?
Give a very brief answer. 1.6. What is the difference between the highest and the lowest Total Labor Force (in %) in Small states?
Make the answer very short. 3.67. What is the difference between the highest and the lowest Total Labor Force (in %) in Costa Rica?
Your answer should be very brief. 8.3. What is the difference between the highest and the lowest Total Labor Force (in %) of Moldova?
Your answer should be very brief. 20.1. 